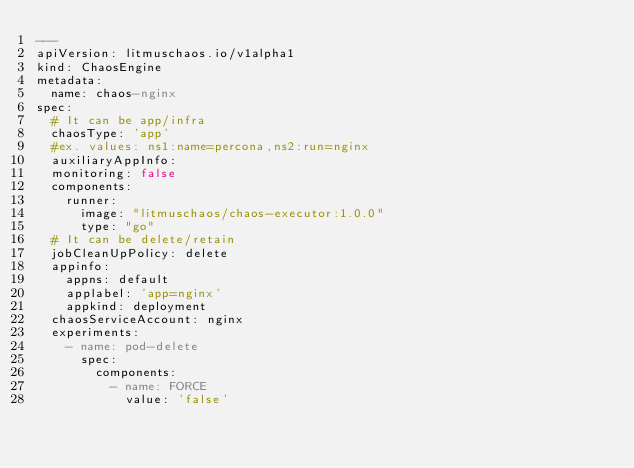<code> <loc_0><loc_0><loc_500><loc_500><_YAML_>---
apiVersion: litmuschaos.io/v1alpha1
kind: ChaosEngine
metadata:
  name: chaos-nginx
spec:
  # It can be app/infra
  chaosType: 'app'
  #ex. values: ns1:name=percona,ns2:run=nginx 
  auxiliaryAppInfo: 
  monitoring: false
  components:
    runner:
      image: "litmuschaos/chaos-executor:1.0.0"
      type: "go"
  # It can be delete/retain
  jobCleanUpPolicy: delete 
  appinfo:
    appns: default
    applabel: 'app=nginx'
    appkind: deployment
  chaosServiceAccount: nginx
  experiments:
    - name: pod-delete
      spec:
        components:
          - name: FORCE
            value: 'false'

</code> 